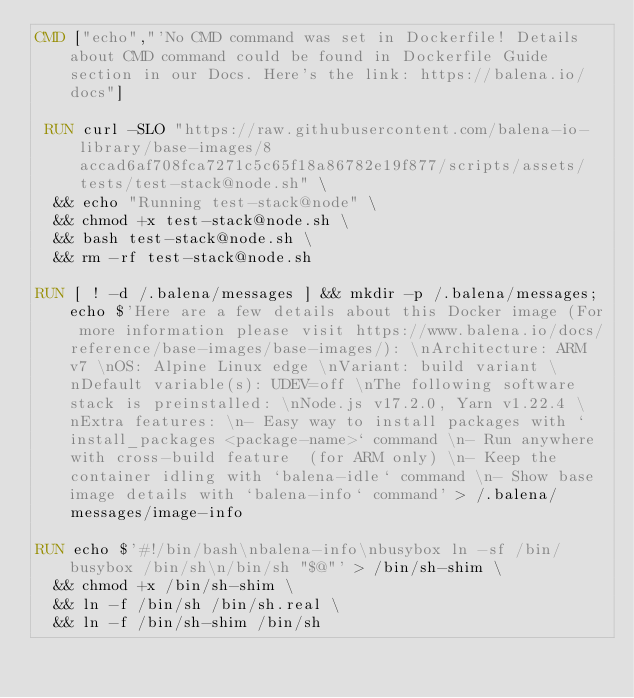<code> <loc_0><loc_0><loc_500><loc_500><_Dockerfile_>CMD ["echo","'No CMD command was set in Dockerfile! Details about CMD command could be found in Dockerfile Guide section in our Docs. Here's the link: https://balena.io/docs"]

 RUN curl -SLO "https://raw.githubusercontent.com/balena-io-library/base-images/8accad6af708fca7271c5c65f18a86782e19f877/scripts/assets/tests/test-stack@node.sh" \
  && echo "Running test-stack@node" \
  && chmod +x test-stack@node.sh \
  && bash test-stack@node.sh \
  && rm -rf test-stack@node.sh 

RUN [ ! -d /.balena/messages ] && mkdir -p /.balena/messages; echo $'Here are a few details about this Docker image (For more information please visit https://www.balena.io/docs/reference/base-images/base-images/): \nArchitecture: ARM v7 \nOS: Alpine Linux edge \nVariant: build variant \nDefault variable(s): UDEV=off \nThe following software stack is preinstalled: \nNode.js v17.2.0, Yarn v1.22.4 \nExtra features: \n- Easy way to install packages with `install_packages <package-name>` command \n- Run anywhere with cross-build feature  (for ARM only) \n- Keep the container idling with `balena-idle` command \n- Show base image details with `balena-info` command' > /.balena/messages/image-info

RUN echo $'#!/bin/bash\nbalena-info\nbusybox ln -sf /bin/busybox /bin/sh\n/bin/sh "$@"' > /bin/sh-shim \
	&& chmod +x /bin/sh-shim \
	&& ln -f /bin/sh /bin/sh.real \
	&& ln -f /bin/sh-shim /bin/sh</code> 